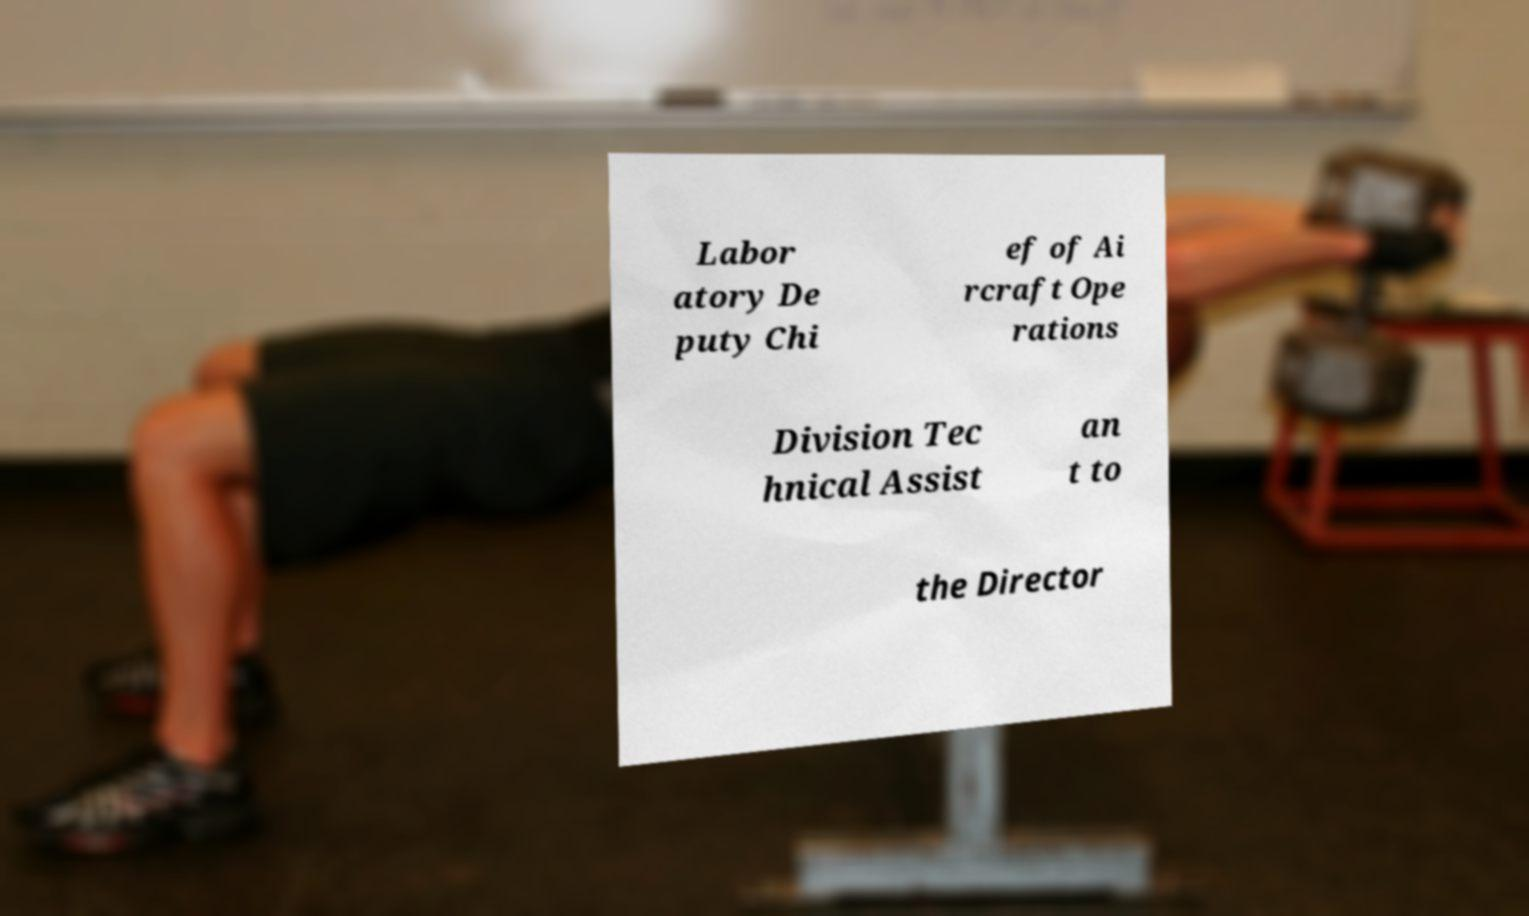Could you assist in decoding the text presented in this image and type it out clearly? Labor atory De puty Chi ef of Ai rcraft Ope rations Division Tec hnical Assist an t to the Director 